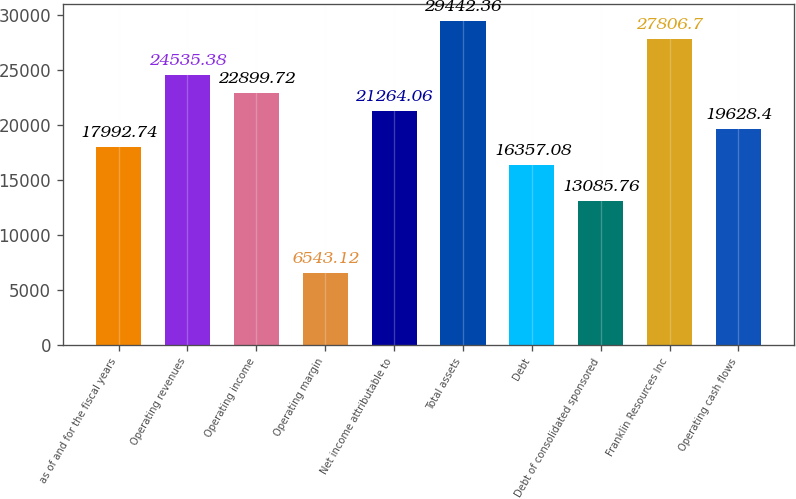Convert chart to OTSL. <chart><loc_0><loc_0><loc_500><loc_500><bar_chart><fcel>as of and for the fiscal years<fcel>Operating revenues<fcel>Operating income<fcel>Operating margin<fcel>Net income attributable to<fcel>Total assets<fcel>Debt<fcel>Debt of consolidated sponsored<fcel>Franklin Resources Inc<fcel>Operating cash flows<nl><fcel>17992.7<fcel>24535.4<fcel>22899.7<fcel>6543.12<fcel>21264.1<fcel>29442.4<fcel>16357.1<fcel>13085.8<fcel>27806.7<fcel>19628.4<nl></chart> 